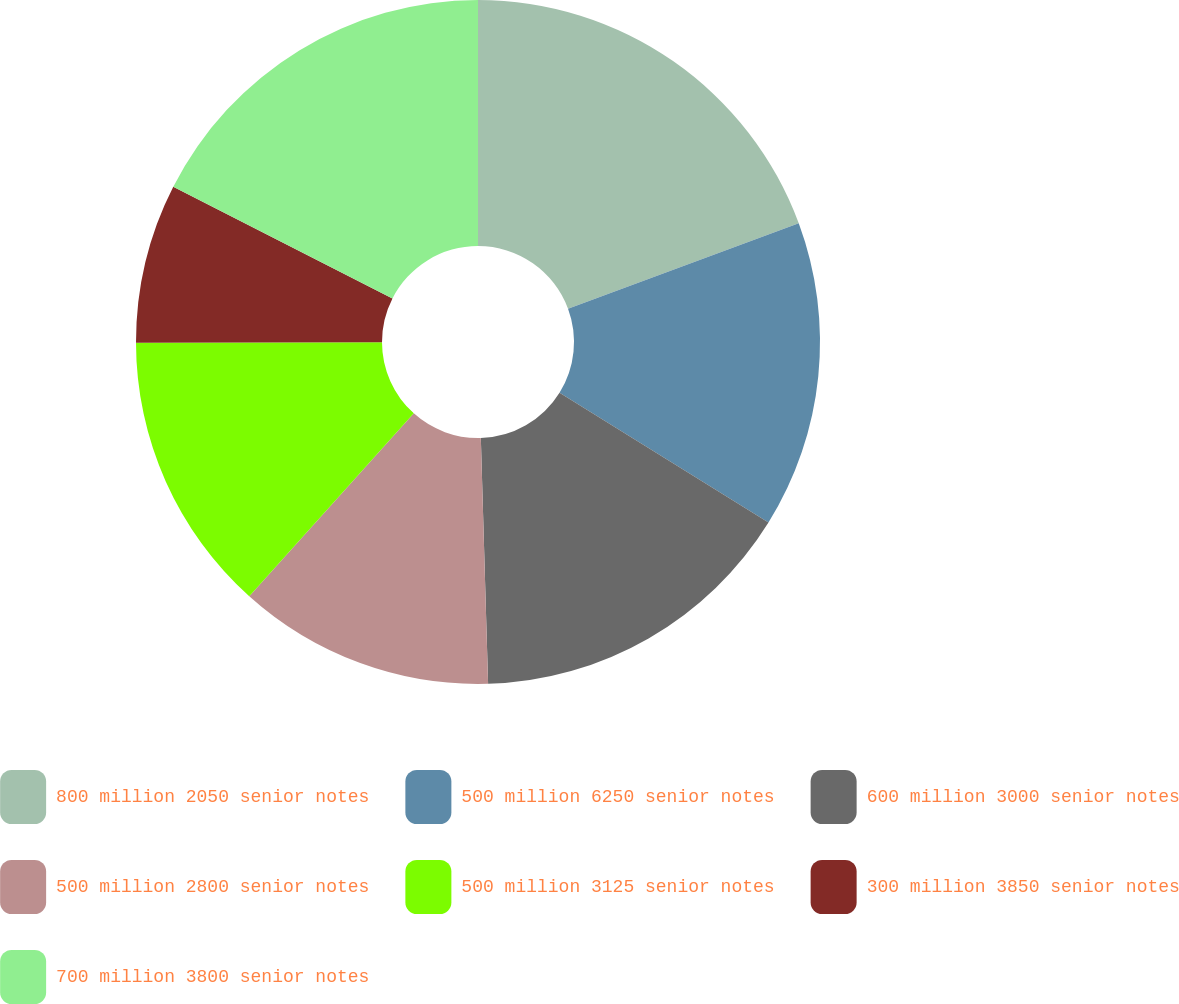<chart> <loc_0><loc_0><loc_500><loc_500><pie_chart><fcel>800 million 2050 senior notes<fcel>500 million 6250 senior notes<fcel>600 million 3000 senior notes<fcel>500 million 2800 senior notes<fcel>500 million 3125 senior notes<fcel>300 million 3850 senior notes<fcel>700 million 3800 senior notes<nl><fcel>19.36%<fcel>14.49%<fcel>15.68%<fcel>12.13%<fcel>13.31%<fcel>7.53%<fcel>17.5%<nl></chart> 